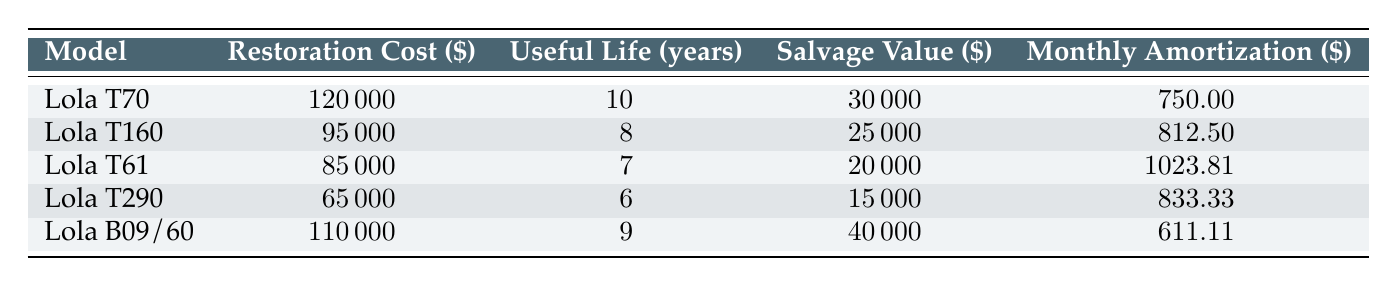What's the restoration cost of the Lola T70? The table lists the restoration cost for the Lola T70 as \$120,000.
Answer: 120000 What is the useful life of the Lola T160? The table indicates that the useful life of the Lola T160 is 8 years.
Answer: 8 Which model has the highest monthly amortization? By comparing the monthly amortization values, the Lola T61 has the highest value at \$1,023.81.
Answer: Lola T61 What is the total restoration cost of all models combined? The total restoration cost is calculated by summing the restoration costs: \$120,000 + \$95,000 + \$85,000 + \$65,000 + \$110,000 = \$475,000.
Answer: 475000 Is the salvage value of the Lola T290 greater than that of the Lola B09/60? The salvage value of the Lola T290 is \$15,000, while the salvage value of the Lola B09/60 is \$40,000. Therefore, the salvage value of the Lola T290 is not greater.
Answer: No What is the average monthly amortization across all models? To find the average monthly amortization, sum the values: \$750 + \$812.50 + \$1,023.81 + \$833.33 + \$611.11 = \$4030.75. Divide by 5 (the number of models) to get \(4030.75 / 5 = 806.15\).
Answer: 806.15 How many models have a salvage value less than \$30,000? Based on the table, the Lola T290 has a salvage value of \$15,000, and the Lola T61 has a salvage value of \$20,000, both of which are less than \$30,000. Thus, there are 2 models with a salvage value below that threshold.
Answer: 2 Which model has the longest useful life? By reviewing the useful life column, the Lola T70 has the longest useful life at 10 years.
Answer: Lola T70 Does the Lola B09/60 have a higher restoration cost than both the Lola T290 and Lola T160? The restoration cost of the Lola B09/60 is \$110,000, which is higher than the Lola T290 cost of \$65,000 and the Lola T160 cost of \$95,000. Hence, the statement is true.
Answer: Yes 